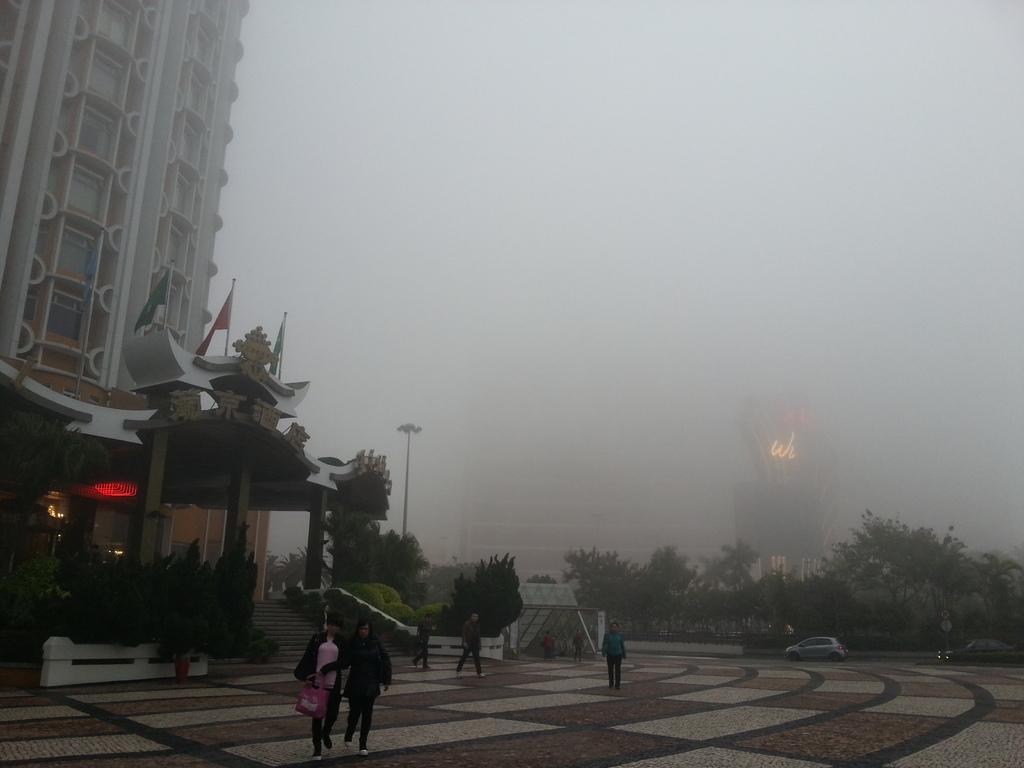In one or two sentences, can you explain what this image depicts? At the bottom there are two persons who are holding a bag, beside them we can see a man who is wearing a blue hoodie and trouser. Near to the stairs there are two persons were walking. In the background we can see the street light, shade, trees and tower. On the left we can see the building. At the top we can see the fog. 